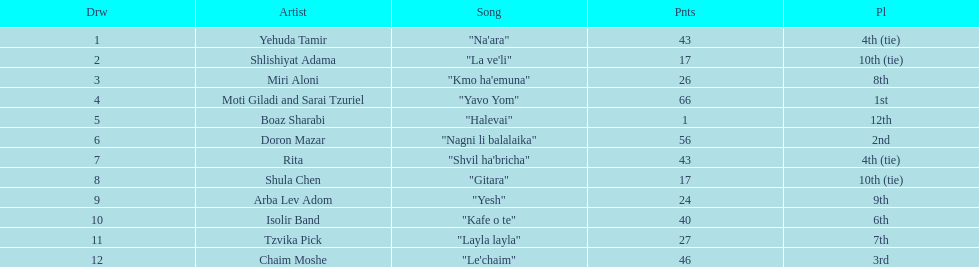How many artists are there? Yehuda Tamir, Shlishiyat Adama, Miri Aloni, Moti Giladi and Sarai Tzuriel, Boaz Sharabi, Doron Mazar, Rita, Shula Chen, Arba Lev Adom, Isolir Band, Tzvika Pick, Chaim Moshe. What is the least amount of points awarded? 1. Can you give me this table as a dict? {'header': ['Drw', 'Artist', 'Song', 'Pnts', 'Pl'], 'rows': [['1', 'Yehuda Tamir', '"Na\'ara"', '43', '4th (tie)'], ['2', 'Shlishiyat Adama', '"La ve\'li"', '17', '10th (tie)'], ['3', 'Miri Aloni', '"Kmo ha\'emuna"', '26', '8th'], ['4', 'Moti Giladi and Sarai Tzuriel', '"Yavo Yom"', '66', '1st'], ['5', 'Boaz Sharabi', '"Halevai"', '1', '12th'], ['6', 'Doron Mazar', '"Nagni li balalaika"', '56', '2nd'], ['7', 'Rita', '"Shvil ha\'bricha"', '43', '4th (tie)'], ['8', 'Shula Chen', '"Gitara"', '17', '10th (tie)'], ['9', 'Arba Lev Adom', '"Yesh"', '24', '9th'], ['10', 'Isolir Band', '"Kafe o te"', '40', '6th'], ['11', 'Tzvika Pick', '"Layla layla"', '27', '7th'], ['12', 'Chaim Moshe', '"Le\'chaim"', '46', '3rd']]} Who was the artist awarded those points? Boaz Sharabi. 